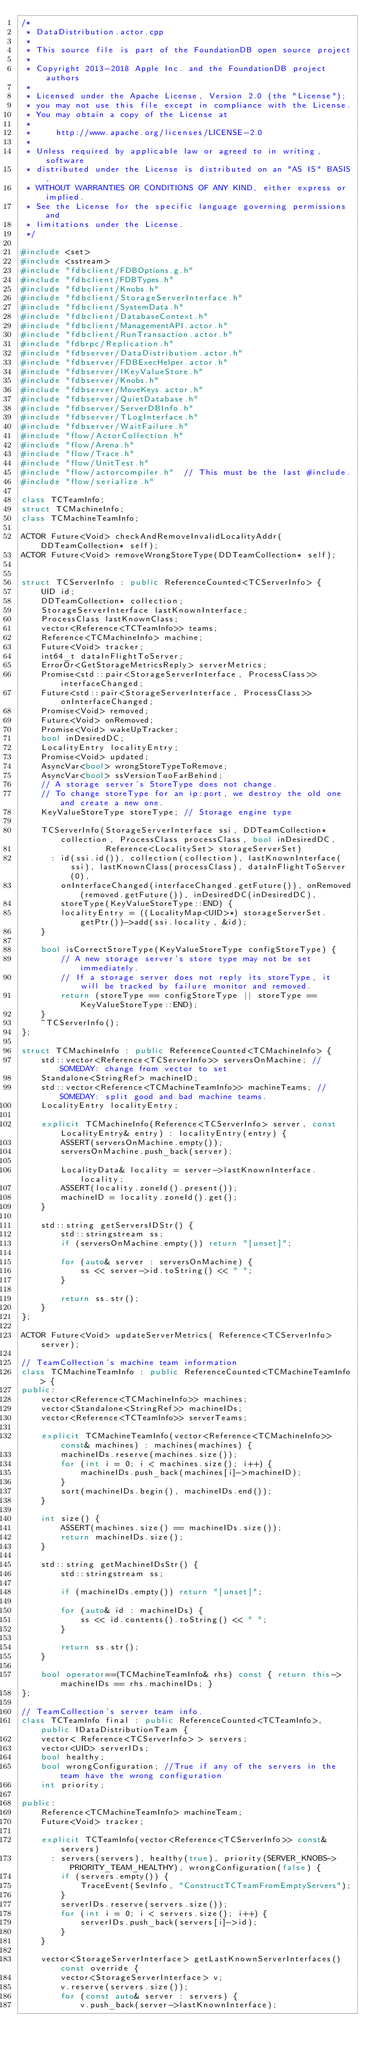<code> <loc_0><loc_0><loc_500><loc_500><_C++_>/*
 * DataDistribution.actor.cpp
 *
 * This source file is part of the FoundationDB open source project
 *
 * Copyright 2013-2018 Apple Inc. and the FoundationDB project authors
 *
 * Licensed under the Apache License, Version 2.0 (the "License");
 * you may not use this file except in compliance with the License.
 * You may obtain a copy of the License at
 *
 *     http://www.apache.org/licenses/LICENSE-2.0
 *
 * Unless required by applicable law or agreed to in writing, software
 * distributed under the License is distributed on an "AS IS" BASIS,
 * WITHOUT WARRANTIES OR CONDITIONS OF ANY KIND, either express or implied.
 * See the License for the specific language governing permissions and
 * limitations under the License.
 */

#include <set>
#include <sstream>
#include "fdbclient/FDBOptions.g.h"
#include "fdbclient/FDBTypes.h"
#include "fdbclient/Knobs.h"
#include "fdbclient/StorageServerInterface.h"
#include "fdbclient/SystemData.h"
#include "fdbclient/DatabaseContext.h"
#include "fdbclient/ManagementAPI.actor.h"
#include "fdbclient/RunTransaction.actor.h"
#include "fdbrpc/Replication.h"
#include "fdbserver/DataDistribution.actor.h"
#include "fdbserver/FDBExecHelper.actor.h"
#include "fdbserver/IKeyValueStore.h"
#include "fdbserver/Knobs.h"
#include "fdbserver/MoveKeys.actor.h"
#include "fdbserver/QuietDatabase.h"
#include "fdbserver/ServerDBInfo.h"
#include "fdbserver/TLogInterface.h"
#include "fdbserver/WaitFailure.h"
#include "flow/ActorCollection.h"
#include "flow/Arena.h"
#include "flow/Trace.h"
#include "flow/UnitTest.h"
#include "flow/actorcompiler.h"  // This must be the last #include.
#include "flow/serialize.h"

class TCTeamInfo;
struct TCMachineInfo;
class TCMachineTeamInfo;

ACTOR Future<Void> checkAndRemoveInvalidLocalityAddr(DDTeamCollection* self);
ACTOR Future<Void> removeWrongStoreType(DDTeamCollection* self);


struct TCServerInfo : public ReferenceCounted<TCServerInfo> {
	UID id;
	DDTeamCollection* collection;
	StorageServerInterface lastKnownInterface;
	ProcessClass lastKnownClass;
	vector<Reference<TCTeamInfo>> teams;
	Reference<TCMachineInfo> machine;
	Future<Void> tracker;
	int64_t dataInFlightToServer;
	ErrorOr<GetStorageMetricsReply> serverMetrics;
	Promise<std::pair<StorageServerInterface, ProcessClass>> interfaceChanged;
	Future<std::pair<StorageServerInterface, ProcessClass>> onInterfaceChanged;
	Promise<Void> removed;
	Future<Void> onRemoved;
	Promise<Void> wakeUpTracker;
	bool inDesiredDC;
	LocalityEntry localityEntry;
	Promise<Void> updated;
	AsyncVar<bool> wrongStoreTypeToRemove;
	AsyncVar<bool> ssVersionTooFarBehind;
	// A storage server's StoreType does not change.
	// To change storeType for an ip:port, we destroy the old one and create a new one.
	KeyValueStoreType storeType; // Storage engine type

	TCServerInfo(StorageServerInterface ssi, DDTeamCollection* collection, ProcessClass processClass, bool inDesiredDC,
	             Reference<LocalitySet> storageServerSet)
	  : id(ssi.id()), collection(collection), lastKnownInterface(ssi), lastKnownClass(processClass), dataInFlightToServer(0),
	    onInterfaceChanged(interfaceChanged.getFuture()), onRemoved(removed.getFuture()), inDesiredDC(inDesiredDC),
	    storeType(KeyValueStoreType::END) {
		localityEntry = ((LocalityMap<UID>*) storageServerSet.getPtr())->add(ssi.locality, &id);
	}

	bool isCorrectStoreType(KeyValueStoreType configStoreType) {
		// A new storage server's store type may not be set immediately.
		// If a storage server does not reply its storeType, it will be tracked by failure monitor and removed.
		return (storeType == configStoreType || storeType == KeyValueStoreType::END);
	}
	~TCServerInfo();
};

struct TCMachineInfo : public ReferenceCounted<TCMachineInfo> {
	std::vector<Reference<TCServerInfo>> serversOnMachine; // SOMEDAY: change from vector to set
	Standalone<StringRef> machineID;
	std::vector<Reference<TCMachineTeamInfo>> machineTeams; // SOMEDAY: split good and bad machine teams.
	LocalityEntry localityEntry;

	explicit TCMachineInfo(Reference<TCServerInfo> server, const LocalityEntry& entry) : localityEntry(entry) {
		ASSERT(serversOnMachine.empty());
		serversOnMachine.push_back(server);

		LocalityData& locality = server->lastKnownInterface.locality;
		ASSERT(locality.zoneId().present());
		machineID = locality.zoneId().get();
	}

	std::string getServersIDStr() {
		std::stringstream ss;
		if (serversOnMachine.empty()) return "[unset]";

		for (auto& server : serversOnMachine) {
			ss << server->id.toString() << " ";
		}

		return ss.str();
	}
};

ACTOR Future<Void> updateServerMetrics( Reference<TCServerInfo> server);

// TeamCollection's machine team information
class TCMachineTeamInfo : public ReferenceCounted<TCMachineTeamInfo> {
public:
	vector<Reference<TCMachineInfo>> machines;
	vector<Standalone<StringRef>> machineIDs;
	vector<Reference<TCTeamInfo>> serverTeams;

	explicit TCMachineTeamInfo(vector<Reference<TCMachineInfo>> const& machines) : machines(machines) {
		machineIDs.reserve(machines.size());
		for (int i = 0; i < machines.size(); i++) {
			machineIDs.push_back(machines[i]->machineID);
		}
		sort(machineIDs.begin(), machineIDs.end());
	}

	int size() {
		ASSERT(machines.size() == machineIDs.size());
		return machineIDs.size();
	}

	std::string getMachineIDsStr() {
		std::stringstream ss;

		if (machineIDs.empty()) return "[unset]";

		for (auto& id : machineIDs) {
			ss << id.contents().toString() << " ";
		}

		return ss.str();
	}

	bool operator==(TCMachineTeamInfo& rhs) const { return this->machineIDs == rhs.machineIDs; }
};

// TeamCollection's server team info.
class TCTeamInfo final : public ReferenceCounted<TCTeamInfo>, public IDataDistributionTeam {
	vector< Reference<TCServerInfo> > servers;
	vector<UID> serverIDs;
	bool healthy;
	bool wrongConfiguration; //True if any of the servers in the team have the wrong configuration
	int priority;

public:
	Reference<TCMachineTeamInfo> machineTeam;
	Future<Void> tracker;

	explicit TCTeamInfo(vector<Reference<TCServerInfo>> const& servers)
	  : servers(servers), healthy(true), priority(SERVER_KNOBS->PRIORITY_TEAM_HEALTHY), wrongConfiguration(false) {
		if (servers.empty()) {
			TraceEvent(SevInfo, "ConstructTCTeamFromEmptyServers");
		}
		serverIDs.reserve(servers.size());
		for (int i = 0; i < servers.size(); i++) {
			serverIDs.push_back(servers[i]->id);
		}
	}

	vector<StorageServerInterface> getLastKnownServerInterfaces() const override {
		vector<StorageServerInterface> v;
		v.reserve(servers.size());
		for (const auto& server : servers) {
			v.push_back(server->lastKnownInterface);</code> 